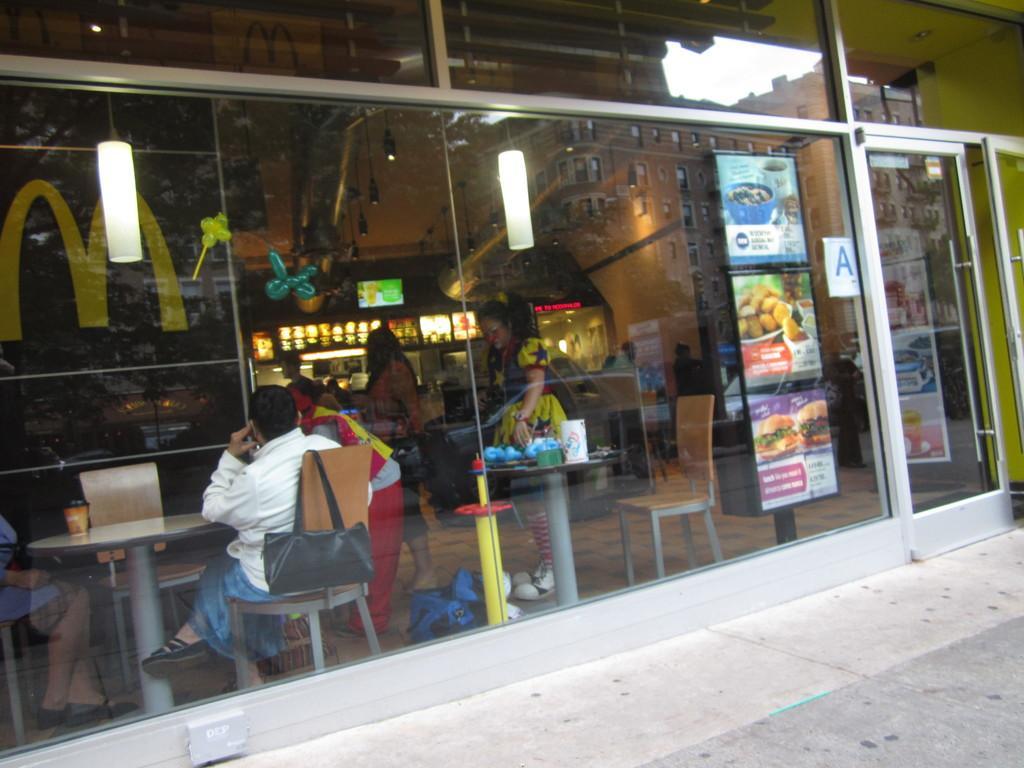In one or two sentences, can you explain what this image depicts? There is glass wall and a door. Through glass wall we can see tables and chairs. On the chairs there are few people sitting. And there is a bag on the chair. On the table there are some items. Also there is a stand with posters. There are lights. In the back there is a banner. In the background there are few people standing. Also there are balloons, lights in the background. On the wall there are some decorations. 